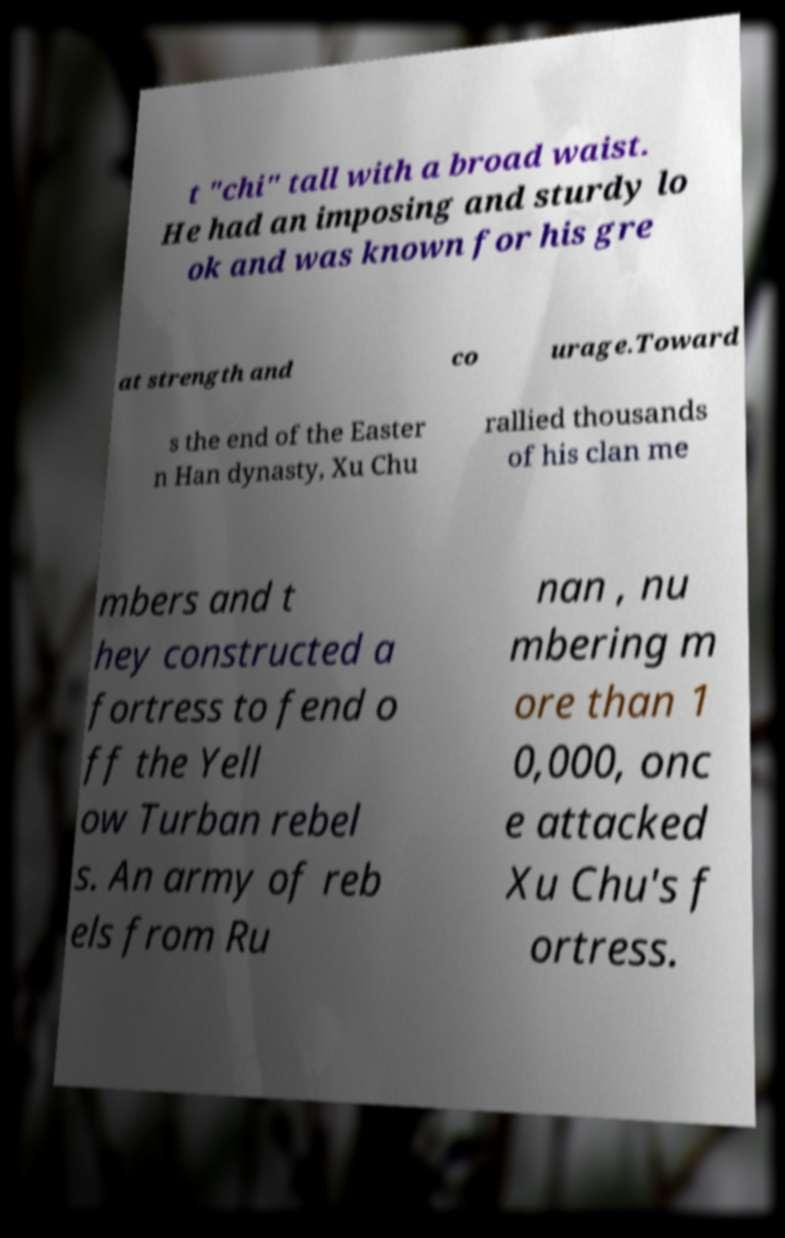There's text embedded in this image that I need extracted. Can you transcribe it verbatim? t "chi" tall with a broad waist. He had an imposing and sturdy lo ok and was known for his gre at strength and co urage.Toward s the end of the Easter n Han dynasty, Xu Chu rallied thousands of his clan me mbers and t hey constructed a fortress to fend o ff the Yell ow Turban rebel s. An army of reb els from Ru nan , nu mbering m ore than 1 0,000, onc e attacked Xu Chu's f ortress. 